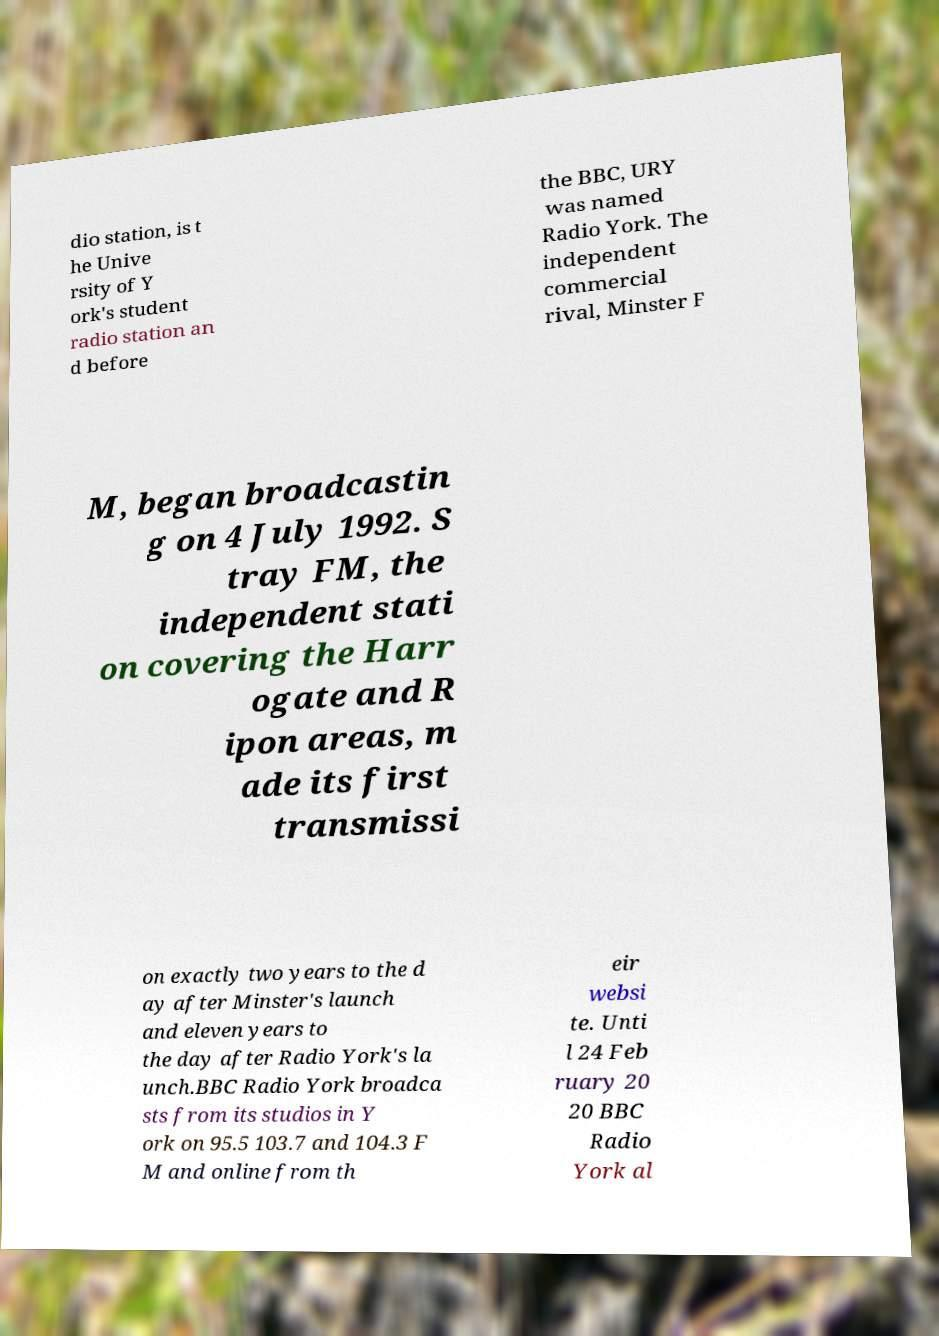Could you assist in decoding the text presented in this image and type it out clearly? dio station, is t he Unive rsity of Y ork's student radio station an d before the BBC, URY was named Radio York. The independent commercial rival, Minster F M, began broadcastin g on 4 July 1992. S tray FM, the independent stati on covering the Harr ogate and R ipon areas, m ade its first transmissi on exactly two years to the d ay after Minster's launch and eleven years to the day after Radio York's la unch.BBC Radio York broadca sts from its studios in Y ork on 95.5 103.7 and 104.3 F M and online from th eir websi te. Unti l 24 Feb ruary 20 20 BBC Radio York al 